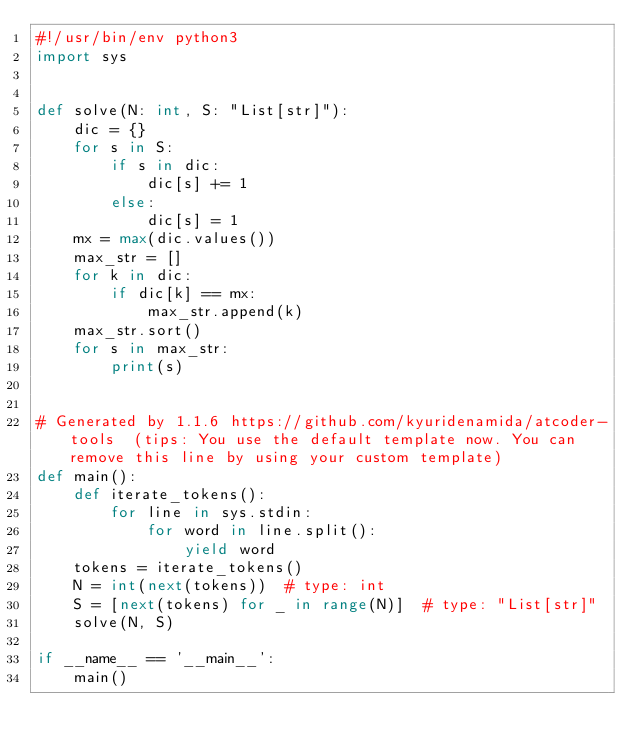Convert code to text. <code><loc_0><loc_0><loc_500><loc_500><_Python_>#!/usr/bin/env python3
import sys


def solve(N: int, S: "List[str]"):
    dic = {}
    for s in S:
        if s in dic:
            dic[s] += 1
        else:
            dic[s] = 1
    mx = max(dic.values())
    max_str = []
    for k in dic:
        if dic[k] == mx:
            max_str.append(k)
    max_str.sort()
    for s in max_str:
        print(s)


# Generated by 1.1.6 https://github.com/kyuridenamida/atcoder-tools  (tips: You use the default template now. You can remove this line by using your custom template)
def main():
    def iterate_tokens():
        for line in sys.stdin:
            for word in line.split():
                yield word
    tokens = iterate_tokens()
    N = int(next(tokens))  # type: int
    S = [next(tokens) for _ in range(N)]  # type: "List[str]"
    solve(N, S)

if __name__ == '__main__':
    main()
</code> 